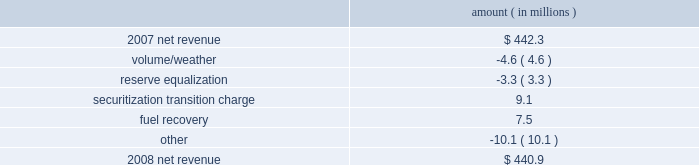Entergy texas , inc .
Management's financial discussion and analysis net revenue 2008 compared to 2007 net revenue consists of operating revenues net of : 1 ) fuel , fuel-related expenses , and gas purchased for resale , 2 ) purchased power expenses , and 3 ) other regulatory charges .
Following is an analysis of the change in net revenue comparing 2008 to 2007 .
Amount ( in millions ) .
The volume/weather variance is primarily due to decreased usage during the unbilled sales period .
See "critical accounting estimates" below and note 1 to the financial statements for further discussion of the accounting for unbilled revenues .
The reserve equalization variance is primarily due to lower reserve equalization revenue related to changes in the entergy system generation mix compared to the same period in 2007 .
The securitization transition charge variance is primarily due to the issuance of securitization bonds .
In june 2007 , entergy gulf states reconstruction funding i , a company wholly-owned and consolidated by entergy texas , issued securitization bonds and with the proceeds purchased from entergy texas the transition property , which is the right to recover from customers through a transition charge amounts sufficient to service the securitization bonds .
See note 5 to the financial statements for additional information regarding the securitization bonds .
The fuel recovery variance is primarily due to a reserve for potential rate refunds made in the first quarter 2007 as a result of a puct ruling related to the application of past puct rulings addressing transition to competition in texas .
The other variance is primarily caused by various operational effects of the jurisdictional separation on revenues and fuel and purchased power expenses .
Gross operating revenues , fuel and purchased power expenses , and other regulatory charges gross operating revenues increased $ 229.3 million primarily due to the following reasons : an increase of $ 157 million in fuel cost recovery revenues due to higher fuel rates and increased usage , partially offset by interim fuel refunds to customers for fuel cost recovery over-collections through november 2007 .
The refund was distributed over a two-month period beginning february 2008 .
The interim refund and the puct approval is discussed in note 2 to the financial statements ; an increase of $ 37.1 million in affiliated wholesale revenue primarily due to increases in the cost of energy ; an increase in transition charge amounts collected from customers to service the securitization bonds as discussed above .
See note 5 to the financial statements for additional information regarding the securitization bonds ; and implementation of an interim surcharge to collect $ 10.3 million in under-recovered incremental purchased capacity costs incurred through july 2007 .
The surcharge was collected over a two-month period beginning february 2008 .
The incremental capacity recovery rider and puct approval is discussed in note 2 to the financial statements. .
What is the net change in net revenue during 2008 for entergy texas , inc.? 
Computations: (440.9 - 442.3)
Answer: -1.4. 